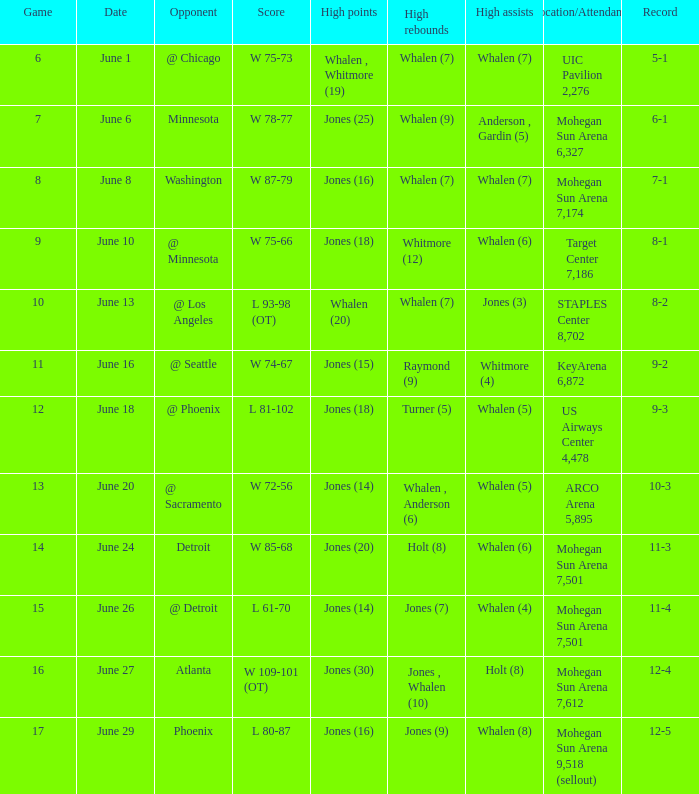Who had the high points on june 8? Jones (16). 